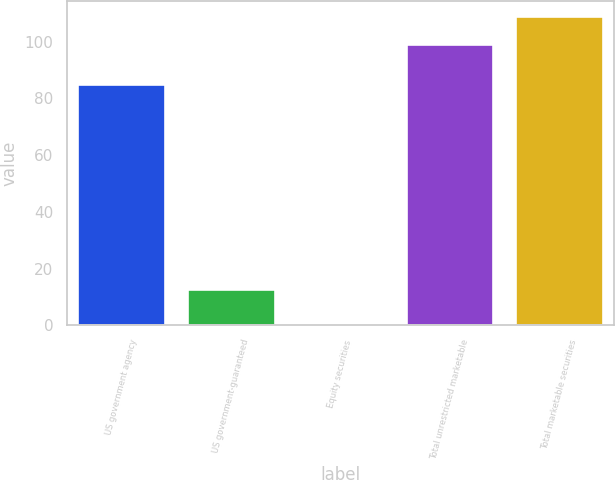Convert chart. <chart><loc_0><loc_0><loc_500><loc_500><bar_chart><fcel>US government agency<fcel>US government-guaranteed<fcel>Equity securities<fcel>Total unrestricted marketable<fcel>Total marketable securities<nl><fcel>85<fcel>13<fcel>1<fcel>99<fcel>108.9<nl></chart> 